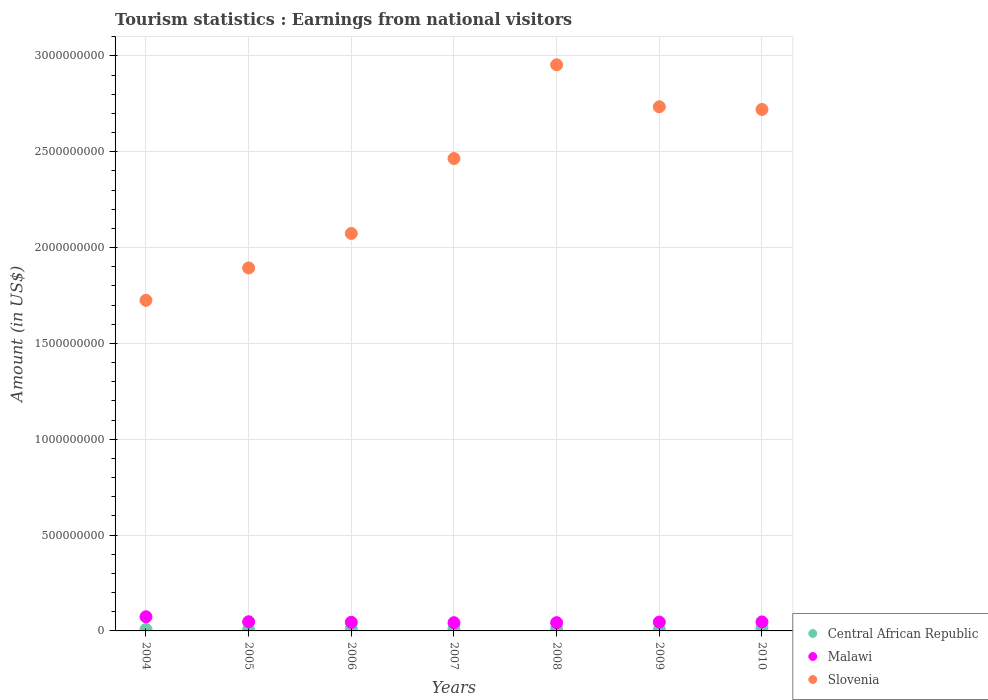How many different coloured dotlines are there?
Your answer should be compact. 3. Is the number of dotlines equal to the number of legend labels?
Provide a succinct answer. Yes. What is the earnings from national visitors in Central African Republic in 2007?
Your answer should be very brief. 1.08e+07. Across all years, what is the maximum earnings from national visitors in Central African Republic?
Make the answer very short. 1.44e+07. Across all years, what is the minimum earnings from national visitors in Central African Republic?
Ensure brevity in your answer.  7.20e+06. What is the total earnings from national visitors in Central African Republic in the graph?
Make the answer very short. 6.97e+07. What is the difference between the earnings from national visitors in Central African Republic in 2008 and that in 2010?
Provide a short and direct response. -2.60e+06. What is the difference between the earnings from national visitors in Central African Republic in 2010 and the earnings from national visitors in Slovenia in 2009?
Ensure brevity in your answer.  -2.72e+09. What is the average earnings from national visitors in Slovenia per year?
Your answer should be very brief. 2.37e+09. In the year 2006, what is the difference between the earnings from national visitors in Slovenia and earnings from national visitors in Central African Republic?
Offer a terse response. 2.06e+09. What is the ratio of the earnings from national visitors in Slovenia in 2004 to that in 2010?
Offer a very short reply. 0.63. Is the difference between the earnings from national visitors in Slovenia in 2004 and 2009 greater than the difference between the earnings from national visitors in Central African Republic in 2004 and 2009?
Provide a succinct answer. No. What is the difference between the highest and the second highest earnings from national visitors in Malawi?
Provide a succinct answer. 2.60e+07. What is the difference between the highest and the lowest earnings from national visitors in Slovenia?
Give a very brief answer. 1.23e+09. Is the earnings from national visitors in Slovenia strictly greater than the earnings from national visitors in Central African Republic over the years?
Offer a very short reply. Yes. How many dotlines are there?
Your answer should be very brief. 3. How many years are there in the graph?
Ensure brevity in your answer.  7. Does the graph contain any zero values?
Your response must be concise. No. Does the graph contain grids?
Your answer should be very brief. Yes. Where does the legend appear in the graph?
Offer a very short reply. Bottom right. How are the legend labels stacked?
Give a very brief answer. Vertical. What is the title of the graph?
Ensure brevity in your answer.  Tourism statistics : Earnings from national visitors. What is the label or title of the X-axis?
Offer a terse response. Years. What is the label or title of the Y-axis?
Make the answer very short. Amount (in US$). What is the Amount (in US$) of Central African Republic in 2004?
Your answer should be very brief. 7.80e+06. What is the Amount (in US$) of Malawi in 2004?
Make the answer very short. 7.40e+07. What is the Amount (in US$) of Slovenia in 2004?
Provide a succinct answer. 1.72e+09. What is the Amount (in US$) in Central African Republic in 2005?
Offer a terse response. 7.20e+06. What is the Amount (in US$) in Malawi in 2005?
Give a very brief answer. 4.80e+07. What is the Amount (in US$) in Slovenia in 2005?
Offer a very short reply. 1.89e+09. What is the Amount (in US$) in Central African Republic in 2006?
Give a very brief answer. 1.02e+07. What is the Amount (in US$) of Malawi in 2006?
Your response must be concise. 4.50e+07. What is the Amount (in US$) in Slovenia in 2006?
Ensure brevity in your answer.  2.07e+09. What is the Amount (in US$) of Central African Republic in 2007?
Offer a very short reply. 1.08e+07. What is the Amount (in US$) in Malawi in 2007?
Ensure brevity in your answer.  4.30e+07. What is the Amount (in US$) of Slovenia in 2007?
Offer a very short reply. 2.46e+09. What is the Amount (in US$) in Central African Republic in 2008?
Provide a succinct answer. 1.18e+07. What is the Amount (in US$) of Malawi in 2008?
Make the answer very short. 4.30e+07. What is the Amount (in US$) of Slovenia in 2008?
Ensure brevity in your answer.  2.95e+09. What is the Amount (in US$) of Central African Republic in 2009?
Offer a terse response. 7.50e+06. What is the Amount (in US$) in Malawi in 2009?
Offer a very short reply. 4.60e+07. What is the Amount (in US$) in Slovenia in 2009?
Ensure brevity in your answer.  2.74e+09. What is the Amount (in US$) of Central African Republic in 2010?
Make the answer very short. 1.44e+07. What is the Amount (in US$) of Malawi in 2010?
Give a very brief answer. 4.70e+07. What is the Amount (in US$) of Slovenia in 2010?
Ensure brevity in your answer.  2.72e+09. Across all years, what is the maximum Amount (in US$) in Central African Republic?
Keep it short and to the point. 1.44e+07. Across all years, what is the maximum Amount (in US$) in Malawi?
Keep it short and to the point. 7.40e+07. Across all years, what is the maximum Amount (in US$) in Slovenia?
Your answer should be very brief. 2.95e+09. Across all years, what is the minimum Amount (in US$) in Central African Republic?
Your response must be concise. 7.20e+06. Across all years, what is the minimum Amount (in US$) of Malawi?
Give a very brief answer. 4.30e+07. Across all years, what is the minimum Amount (in US$) of Slovenia?
Give a very brief answer. 1.72e+09. What is the total Amount (in US$) of Central African Republic in the graph?
Give a very brief answer. 6.97e+07. What is the total Amount (in US$) in Malawi in the graph?
Your response must be concise. 3.46e+08. What is the total Amount (in US$) in Slovenia in the graph?
Make the answer very short. 1.66e+1. What is the difference between the Amount (in US$) in Malawi in 2004 and that in 2005?
Keep it short and to the point. 2.60e+07. What is the difference between the Amount (in US$) in Slovenia in 2004 and that in 2005?
Ensure brevity in your answer.  -1.69e+08. What is the difference between the Amount (in US$) in Central African Republic in 2004 and that in 2006?
Provide a succinct answer. -2.40e+06. What is the difference between the Amount (in US$) of Malawi in 2004 and that in 2006?
Ensure brevity in your answer.  2.90e+07. What is the difference between the Amount (in US$) of Slovenia in 2004 and that in 2006?
Offer a terse response. -3.49e+08. What is the difference between the Amount (in US$) in Central African Republic in 2004 and that in 2007?
Make the answer very short. -3.00e+06. What is the difference between the Amount (in US$) in Malawi in 2004 and that in 2007?
Keep it short and to the point. 3.10e+07. What is the difference between the Amount (in US$) of Slovenia in 2004 and that in 2007?
Offer a terse response. -7.40e+08. What is the difference between the Amount (in US$) of Central African Republic in 2004 and that in 2008?
Provide a short and direct response. -4.00e+06. What is the difference between the Amount (in US$) in Malawi in 2004 and that in 2008?
Your answer should be very brief. 3.10e+07. What is the difference between the Amount (in US$) in Slovenia in 2004 and that in 2008?
Your response must be concise. -1.23e+09. What is the difference between the Amount (in US$) in Malawi in 2004 and that in 2009?
Provide a succinct answer. 2.80e+07. What is the difference between the Amount (in US$) of Slovenia in 2004 and that in 2009?
Your answer should be very brief. -1.01e+09. What is the difference between the Amount (in US$) in Central African Republic in 2004 and that in 2010?
Your answer should be very brief. -6.60e+06. What is the difference between the Amount (in US$) in Malawi in 2004 and that in 2010?
Offer a very short reply. 2.70e+07. What is the difference between the Amount (in US$) in Slovenia in 2004 and that in 2010?
Offer a terse response. -9.96e+08. What is the difference between the Amount (in US$) of Slovenia in 2005 and that in 2006?
Your answer should be very brief. -1.80e+08. What is the difference between the Amount (in US$) in Central African Republic in 2005 and that in 2007?
Offer a terse response. -3.60e+06. What is the difference between the Amount (in US$) of Slovenia in 2005 and that in 2007?
Keep it short and to the point. -5.71e+08. What is the difference between the Amount (in US$) in Central African Republic in 2005 and that in 2008?
Your answer should be compact. -4.60e+06. What is the difference between the Amount (in US$) in Malawi in 2005 and that in 2008?
Offer a very short reply. 5.00e+06. What is the difference between the Amount (in US$) of Slovenia in 2005 and that in 2008?
Provide a succinct answer. -1.06e+09. What is the difference between the Amount (in US$) in Malawi in 2005 and that in 2009?
Keep it short and to the point. 2.00e+06. What is the difference between the Amount (in US$) of Slovenia in 2005 and that in 2009?
Provide a short and direct response. -8.41e+08. What is the difference between the Amount (in US$) of Central African Republic in 2005 and that in 2010?
Keep it short and to the point. -7.20e+06. What is the difference between the Amount (in US$) of Malawi in 2005 and that in 2010?
Offer a terse response. 1.00e+06. What is the difference between the Amount (in US$) of Slovenia in 2005 and that in 2010?
Give a very brief answer. -8.27e+08. What is the difference between the Amount (in US$) of Central African Republic in 2006 and that in 2007?
Provide a succinct answer. -6.00e+05. What is the difference between the Amount (in US$) in Slovenia in 2006 and that in 2007?
Your answer should be compact. -3.91e+08. What is the difference between the Amount (in US$) in Central African Republic in 2006 and that in 2008?
Your response must be concise. -1.60e+06. What is the difference between the Amount (in US$) of Malawi in 2006 and that in 2008?
Ensure brevity in your answer.  2.00e+06. What is the difference between the Amount (in US$) in Slovenia in 2006 and that in 2008?
Your answer should be very brief. -8.80e+08. What is the difference between the Amount (in US$) in Central African Republic in 2006 and that in 2009?
Keep it short and to the point. 2.70e+06. What is the difference between the Amount (in US$) of Malawi in 2006 and that in 2009?
Make the answer very short. -1.00e+06. What is the difference between the Amount (in US$) in Slovenia in 2006 and that in 2009?
Provide a short and direct response. -6.61e+08. What is the difference between the Amount (in US$) in Central African Republic in 2006 and that in 2010?
Provide a succinct answer. -4.20e+06. What is the difference between the Amount (in US$) in Malawi in 2006 and that in 2010?
Your response must be concise. -2.00e+06. What is the difference between the Amount (in US$) of Slovenia in 2006 and that in 2010?
Your answer should be compact. -6.47e+08. What is the difference between the Amount (in US$) in Central African Republic in 2007 and that in 2008?
Ensure brevity in your answer.  -1.00e+06. What is the difference between the Amount (in US$) of Slovenia in 2007 and that in 2008?
Provide a short and direct response. -4.89e+08. What is the difference between the Amount (in US$) of Central African Republic in 2007 and that in 2009?
Your response must be concise. 3.30e+06. What is the difference between the Amount (in US$) of Slovenia in 2007 and that in 2009?
Your response must be concise. -2.70e+08. What is the difference between the Amount (in US$) of Central African Republic in 2007 and that in 2010?
Make the answer very short. -3.60e+06. What is the difference between the Amount (in US$) of Slovenia in 2007 and that in 2010?
Your response must be concise. -2.56e+08. What is the difference between the Amount (in US$) of Central African Republic in 2008 and that in 2009?
Provide a succinct answer. 4.30e+06. What is the difference between the Amount (in US$) of Slovenia in 2008 and that in 2009?
Your response must be concise. 2.19e+08. What is the difference between the Amount (in US$) of Central African Republic in 2008 and that in 2010?
Offer a terse response. -2.60e+06. What is the difference between the Amount (in US$) in Malawi in 2008 and that in 2010?
Your response must be concise. -4.00e+06. What is the difference between the Amount (in US$) of Slovenia in 2008 and that in 2010?
Your answer should be compact. 2.33e+08. What is the difference between the Amount (in US$) in Central African Republic in 2009 and that in 2010?
Your response must be concise. -6.90e+06. What is the difference between the Amount (in US$) in Malawi in 2009 and that in 2010?
Provide a short and direct response. -1.00e+06. What is the difference between the Amount (in US$) of Slovenia in 2009 and that in 2010?
Your answer should be very brief. 1.40e+07. What is the difference between the Amount (in US$) in Central African Republic in 2004 and the Amount (in US$) in Malawi in 2005?
Your answer should be very brief. -4.02e+07. What is the difference between the Amount (in US$) of Central African Republic in 2004 and the Amount (in US$) of Slovenia in 2005?
Provide a short and direct response. -1.89e+09. What is the difference between the Amount (in US$) of Malawi in 2004 and the Amount (in US$) of Slovenia in 2005?
Give a very brief answer. -1.82e+09. What is the difference between the Amount (in US$) in Central African Republic in 2004 and the Amount (in US$) in Malawi in 2006?
Ensure brevity in your answer.  -3.72e+07. What is the difference between the Amount (in US$) in Central African Republic in 2004 and the Amount (in US$) in Slovenia in 2006?
Ensure brevity in your answer.  -2.07e+09. What is the difference between the Amount (in US$) of Malawi in 2004 and the Amount (in US$) of Slovenia in 2006?
Your response must be concise. -2.00e+09. What is the difference between the Amount (in US$) of Central African Republic in 2004 and the Amount (in US$) of Malawi in 2007?
Keep it short and to the point. -3.52e+07. What is the difference between the Amount (in US$) in Central African Republic in 2004 and the Amount (in US$) in Slovenia in 2007?
Give a very brief answer. -2.46e+09. What is the difference between the Amount (in US$) in Malawi in 2004 and the Amount (in US$) in Slovenia in 2007?
Ensure brevity in your answer.  -2.39e+09. What is the difference between the Amount (in US$) in Central African Republic in 2004 and the Amount (in US$) in Malawi in 2008?
Your response must be concise. -3.52e+07. What is the difference between the Amount (in US$) in Central African Republic in 2004 and the Amount (in US$) in Slovenia in 2008?
Your answer should be very brief. -2.95e+09. What is the difference between the Amount (in US$) of Malawi in 2004 and the Amount (in US$) of Slovenia in 2008?
Your response must be concise. -2.88e+09. What is the difference between the Amount (in US$) of Central African Republic in 2004 and the Amount (in US$) of Malawi in 2009?
Offer a very short reply. -3.82e+07. What is the difference between the Amount (in US$) of Central African Republic in 2004 and the Amount (in US$) of Slovenia in 2009?
Give a very brief answer. -2.73e+09. What is the difference between the Amount (in US$) of Malawi in 2004 and the Amount (in US$) of Slovenia in 2009?
Offer a terse response. -2.66e+09. What is the difference between the Amount (in US$) in Central African Republic in 2004 and the Amount (in US$) in Malawi in 2010?
Provide a succinct answer. -3.92e+07. What is the difference between the Amount (in US$) of Central African Republic in 2004 and the Amount (in US$) of Slovenia in 2010?
Offer a very short reply. -2.71e+09. What is the difference between the Amount (in US$) of Malawi in 2004 and the Amount (in US$) of Slovenia in 2010?
Make the answer very short. -2.65e+09. What is the difference between the Amount (in US$) in Central African Republic in 2005 and the Amount (in US$) in Malawi in 2006?
Provide a short and direct response. -3.78e+07. What is the difference between the Amount (in US$) in Central African Republic in 2005 and the Amount (in US$) in Slovenia in 2006?
Make the answer very short. -2.07e+09. What is the difference between the Amount (in US$) in Malawi in 2005 and the Amount (in US$) in Slovenia in 2006?
Offer a very short reply. -2.03e+09. What is the difference between the Amount (in US$) in Central African Republic in 2005 and the Amount (in US$) in Malawi in 2007?
Give a very brief answer. -3.58e+07. What is the difference between the Amount (in US$) in Central African Republic in 2005 and the Amount (in US$) in Slovenia in 2007?
Your answer should be very brief. -2.46e+09. What is the difference between the Amount (in US$) in Malawi in 2005 and the Amount (in US$) in Slovenia in 2007?
Offer a very short reply. -2.42e+09. What is the difference between the Amount (in US$) in Central African Republic in 2005 and the Amount (in US$) in Malawi in 2008?
Offer a very short reply. -3.58e+07. What is the difference between the Amount (in US$) in Central African Republic in 2005 and the Amount (in US$) in Slovenia in 2008?
Offer a terse response. -2.95e+09. What is the difference between the Amount (in US$) of Malawi in 2005 and the Amount (in US$) of Slovenia in 2008?
Offer a very short reply. -2.91e+09. What is the difference between the Amount (in US$) in Central African Republic in 2005 and the Amount (in US$) in Malawi in 2009?
Provide a short and direct response. -3.88e+07. What is the difference between the Amount (in US$) of Central African Republic in 2005 and the Amount (in US$) of Slovenia in 2009?
Your answer should be very brief. -2.73e+09. What is the difference between the Amount (in US$) in Malawi in 2005 and the Amount (in US$) in Slovenia in 2009?
Keep it short and to the point. -2.69e+09. What is the difference between the Amount (in US$) of Central African Republic in 2005 and the Amount (in US$) of Malawi in 2010?
Give a very brief answer. -3.98e+07. What is the difference between the Amount (in US$) in Central African Republic in 2005 and the Amount (in US$) in Slovenia in 2010?
Offer a terse response. -2.71e+09. What is the difference between the Amount (in US$) in Malawi in 2005 and the Amount (in US$) in Slovenia in 2010?
Provide a succinct answer. -2.67e+09. What is the difference between the Amount (in US$) in Central African Republic in 2006 and the Amount (in US$) in Malawi in 2007?
Make the answer very short. -3.28e+07. What is the difference between the Amount (in US$) in Central African Republic in 2006 and the Amount (in US$) in Slovenia in 2007?
Your response must be concise. -2.45e+09. What is the difference between the Amount (in US$) in Malawi in 2006 and the Amount (in US$) in Slovenia in 2007?
Offer a terse response. -2.42e+09. What is the difference between the Amount (in US$) in Central African Republic in 2006 and the Amount (in US$) in Malawi in 2008?
Offer a very short reply. -3.28e+07. What is the difference between the Amount (in US$) of Central African Republic in 2006 and the Amount (in US$) of Slovenia in 2008?
Keep it short and to the point. -2.94e+09. What is the difference between the Amount (in US$) in Malawi in 2006 and the Amount (in US$) in Slovenia in 2008?
Provide a succinct answer. -2.91e+09. What is the difference between the Amount (in US$) in Central African Republic in 2006 and the Amount (in US$) in Malawi in 2009?
Give a very brief answer. -3.58e+07. What is the difference between the Amount (in US$) in Central African Republic in 2006 and the Amount (in US$) in Slovenia in 2009?
Offer a terse response. -2.72e+09. What is the difference between the Amount (in US$) of Malawi in 2006 and the Amount (in US$) of Slovenia in 2009?
Provide a succinct answer. -2.69e+09. What is the difference between the Amount (in US$) in Central African Republic in 2006 and the Amount (in US$) in Malawi in 2010?
Your answer should be compact. -3.68e+07. What is the difference between the Amount (in US$) in Central African Republic in 2006 and the Amount (in US$) in Slovenia in 2010?
Keep it short and to the point. -2.71e+09. What is the difference between the Amount (in US$) in Malawi in 2006 and the Amount (in US$) in Slovenia in 2010?
Make the answer very short. -2.68e+09. What is the difference between the Amount (in US$) of Central African Republic in 2007 and the Amount (in US$) of Malawi in 2008?
Offer a terse response. -3.22e+07. What is the difference between the Amount (in US$) of Central African Republic in 2007 and the Amount (in US$) of Slovenia in 2008?
Provide a short and direct response. -2.94e+09. What is the difference between the Amount (in US$) of Malawi in 2007 and the Amount (in US$) of Slovenia in 2008?
Ensure brevity in your answer.  -2.91e+09. What is the difference between the Amount (in US$) in Central African Republic in 2007 and the Amount (in US$) in Malawi in 2009?
Provide a succinct answer. -3.52e+07. What is the difference between the Amount (in US$) of Central African Republic in 2007 and the Amount (in US$) of Slovenia in 2009?
Give a very brief answer. -2.72e+09. What is the difference between the Amount (in US$) in Malawi in 2007 and the Amount (in US$) in Slovenia in 2009?
Make the answer very short. -2.69e+09. What is the difference between the Amount (in US$) in Central African Republic in 2007 and the Amount (in US$) in Malawi in 2010?
Ensure brevity in your answer.  -3.62e+07. What is the difference between the Amount (in US$) of Central African Republic in 2007 and the Amount (in US$) of Slovenia in 2010?
Offer a very short reply. -2.71e+09. What is the difference between the Amount (in US$) in Malawi in 2007 and the Amount (in US$) in Slovenia in 2010?
Give a very brief answer. -2.68e+09. What is the difference between the Amount (in US$) in Central African Republic in 2008 and the Amount (in US$) in Malawi in 2009?
Keep it short and to the point. -3.42e+07. What is the difference between the Amount (in US$) of Central African Republic in 2008 and the Amount (in US$) of Slovenia in 2009?
Provide a succinct answer. -2.72e+09. What is the difference between the Amount (in US$) in Malawi in 2008 and the Amount (in US$) in Slovenia in 2009?
Ensure brevity in your answer.  -2.69e+09. What is the difference between the Amount (in US$) of Central African Republic in 2008 and the Amount (in US$) of Malawi in 2010?
Offer a terse response. -3.52e+07. What is the difference between the Amount (in US$) of Central African Republic in 2008 and the Amount (in US$) of Slovenia in 2010?
Ensure brevity in your answer.  -2.71e+09. What is the difference between the Amount (in US$) in Malawi in 2008 and the Amount (in US$) in Slovenia in 2010?
Give a very brief answer. -2.68e+09. What is the difference between the Amount (in US$) of Central African Republic in 2009 and the Amount (in US$) of Malawi in 2010?
Provide a succinct answer. -3.95e+07. What is the difference between the Amount (in US$) of Central African Republic in 2009 and the Amount (in US$) of Slovenia in 2010?
Provide a succinct answer. -2.71e+09. What is the difference between the Amount (in US$) in Malawi in 2009 and the Amount (in US$) in Slovenia in 2010?
Your answer should be very brief. -2.68e+09. What is the average Amount (in US$) of Central African Republic per year?
Make the answer very short. 9.96e+06. What is the average Amount (in US$) in Malawi per year?
Provide a short and direct response. 4.94e+07. What is the average Amount (in US$) in Slovenia per year?
Your answer should be compact. 2.37e+09. In the year 2004, what is the difference between the Amount (in US$) of Central African Republic and Amount (in US$) of Malawi?
Ensure brevity in your answer.  -6.62e+07. In the year 2004, what is the difference between the Amount (in US$) in Central African Republic and Amount (in US$) in Slovenia?
Keep it short and to the point. -1.72e+09. In the year 2004, what is the difference between the Amount (in US$) of Malawi and Amount (in US$) of Slovenia?
Make the answer very short. -1.65e+09. In the year 2005, what is the difference between the Amount (in US$) in Central African Republic and Amount (in US$) in Malawi?
Your response must be concise. -4.08e+07. In the year 2005, what is the difference between the Amount (in US$) of Central African Republic and Amount (in US$) of Slovenia?
Provide a short and direct response. -1.89e+09. In the year 2005, what is the difference between the Amount (in US$) of Malawi and Amount (in US$) of Slovenia?
Your answer should be very brief. -1.85e+09. In the year 2006, what is the difference between the Amount (in US$) in Central African Republic and Amount (in US$) in Malawi?
Offer a terse response. -3.48e+07. In the year 2006, what is the difference between the Amount (in US$) in Central African Republic and Amount (in US$) in Slovenia?
Offer a terse response. -2.06e+09. In the year 2006, what is the difference between the Amount (in US$) in Malawi and Amount (in US$) in Slovenia?
Offer a terse response. -2.03e+09. In the year 2007, what is the difference between the Amount (in US$) of Central African Republic and Amount (in US$) of Malawi?
Provide a short and direct response. -3.22e+07. In the year 2007, what is the difference between the Amount (in US$) of Central African Republic and Amount (in US$) of Slovenia?
Offer a very short reply. -2.45e+09. In the year 2007, what is the difference between the Amount (in US$) in Malawi and Amount (in US$) in Slovenia?
Provide a succinct answer. -2.42e+09. In the year 2008, what is the difference between the Amount (in US$) of Central African Republic and Amount (in US$) of Malawi?
Offer a terse response. -3.12e+07. In the year 2008, what is the difference between the Amount (in US$) of Central African Republic and Amount (in US$) of Slovenia?
Your response must be concise. -2.94e+09. In the year 2008, what is the difference between the Amount (in US$) of Malawi and Amount (in US$) of Slovenia?
Provide a succinct answer. -2.91e+09. In the year 2009, what is the difference between the Amount (in US$) in Central African Republic and Amount (in US$) in Malawi?
Keep it short and to the point. -3.85e+07. In the year 2009, what is the difference between the Amount (in US$) in Central African Republic and Amount (in US$) in Slovenia?
Offer a very short reply. -2.73e+09. In the year 2009, what is the difference between the Amount (in US$) of Malawi and Amount (in US$) of Slovenia?
Provide a succinct answer. -2.69e+09. In the year 2010, what is the difference between the Amount (in US$) of Central African Republic and Amount (in US$) of Malawi?
Your answer should be compact. -3.26e+07. In the year 2010, what is the difference between the Amount (in US$) of Central African Republic and Amount (in US$) of Slovenia?
Offer a terse response. -2.71e+09. In the year 2010, what is the difference between the Amount (in US$) of Malawi and Amount (in US$) of Slovenia?
Your answer should be very brief. -2.67e+09. What is the ratio of the Amount (in US$) in Malawi in 2004 to that in 2005?
Offer a terse response. 1.54. What is the ratio of the Amount (in US$) of Slovenia in 2004 to that in 2005?
Offer a terse response. 0.91. What is the ratio of the Amount (in US$) in Central African Republic in 2004 to that in 2006?
Offer a terse response. 0.76. What is the ratio of the Amount (in US$) in Malawi in 2004 to that in 2006?
Provide a succinct answer. 1.64. What is the ratio of the Amount (in US$) in Slovenia in 2004 to that in 2006?
Your response must be concise. 0.83. What is the ratio of the Amount (in US$) in Central African Republic in 2004 to that in 2007?
Ensure brevity in your answer.  0.72. What is the ratio of the Amount (in US$) in Malawi in 2004 to that in 2007?
Give a very brief answer. 1.72. What is the ratio of the Amount (in US$) in Slovenia in 2004 to that in 2007?
Your response must be concise. 0.7. What is the ratio of the Amount (in US$) of Central African Republic in 2004 to that in 2008?
Ensure brevity in your answer.  0.66. What is the ratio of the Amount (in US$) in Malawi in 2004 to that in 2008?
Your answer should be very brief. 1.72. What is the ratio of the Amount (in US$) in Slovenia in 2004 to that in 2008?
Offer a terse response. 0.58. What is the ratio of the Amount (in US$) of Malawi in 2004 to that in 2009?
Your answer should be compact. 1.61. What is the ratio of the Amount (in US$) in Slovenia in 2004 to that in 2009?
Give a very brief answer. 0.63. What is the ratio of the Amount (in US$) in Central African Republic in 2004 to that in 2010?
Ensure brevity in your answer.  0.54. What is the ratio of the Amount (in US$) in Malawi in 2004 to that in 2010?
Make the answer very short. 1.57. What is the ratio of the Amount (in US$) of Slovenia in 2004 to that in 2010?
Provide a succinct answer. 0.63. What is the ratio of the Amount (in US$) in Central African Republic in 2005 to that in 2006?
Give a very brief answer. 0.71. What is the ratio of the Amount (in US$) of Malawi in 2005 to that in 2006?
Make the answer very short. 1.07. What is the ratio of the Amount (in US$) in Slovenia in 2005 to that in 2006?
Offer a terse response. 0.91. What is the ratio of the Amount (in US$) in Malawi in 2005 to that in 2007?
Provide a succinct answer. 1.12. What is the ratio of the Amount (in US$) in Slovenia in 2005 to that in 2007?
Give a very brief answer. 0.77. What is the ratio of the Amount (in US$) in Central African Republic in 2005 to that in 2008?
Your answer should be compact. 0.61. What is the ratio of the Amount (in US$) in Malawi in 2005 to that in 2008?
Your response must be concise. 1.12. What is the ratio of the Amount (in US$) in Slovenia in 2005 to that in 2008?
Keep it short and to the point. 0.64. What is the ratio of the Amount (in US$) in Central African Republic in 2005 to that in 2009?
Ensure brevity in your answer.  0.96. What is the ratio of the Amount (in US$) of Malawi in 2005 to that in 2009?
Keep it short and to the point. 1.04. What is the ratio of the Amount (in US$) of Slovenia in 2005 to that in 2009?
Offer a terse response. 0.69. What is the ratio of the Amount (in US$) in Central African Republic in 2005 to that in 2010?
Provide a short and direct response. 0.5. What is the ratio of the Amount (in US$) of Malawi in 2005 to that in 2010?
Give a very brief answer. 1.02. What is the ratio of the Amount (in US$) in Slovenia in 2005 to that in 2010?
Your response must be concise. 0.7. What is the ratio of the Amount (in US$) of Malawi in 2006 to that in 2007?
Your answer should be very brief. 1.05. What is the ratio of the Amount (in US$) in Slovenia in 2006 to that in 2007?
Make the answer very short. 0.84. What is the ratio of the Amount (in US$) in Central African Republic in 2006 to that in 2008?
Give a very brief answer. 0.86. What is the ratio of the Amount (in US$) of Malawi in 2006 to that in 2008?
Offer a very short reply. 1.05. What is the ratio of the Amount (in US$) of Slovenia in 2006 to that in 2008?
Offer a terse response. 0.7. What is the ratio of the Amount (in US$) of Central African Republic in 2006 to that in 2009?
Your answer should be compact. 1.36. What is the ratio of the Amount (in US$) of Malawi in 2006 to that in 2009?
Offer a terse response. 0.98. What is the ratio of the Amount (in US$) of Slovenia in 2006 to that in 2009?
Keep it short and to the point. 0.76. What is the ratio of the Amount (in US$) in Central African Republic in 2006 to that in 2010?
Give a very brief answer. 0.71. What is the ratio of the Amount (in US$) in Malawi in 2006 to that in 2010?
Provide a short and direct response. 0.96. What is the ratio of the Amount (in US$) of Slovenia in 2006 to that in 2010?
Your response must be concise. 0.76. What is the ratio of the Amount (in US$) in Central African Republic in 2007 to that in 2008?
Give a very brief answer. 0.92. What is the ratio of the Amount (in US$) of Slovenia in 2007 to that in 2008?
Your response must be concise. 0.83. What is the ratio of the Amount (in US$) in Central African Republic in 2007 to that in 2009?
Provide a succinct answer. 1.44. What is the ratio of the Amount (in US$) in Malawi in 2007 to that in 2009?
Offer a terse response. 0.93. What is the ratio of the Amount (in US$) in Slovenia in 2007 to that in 2009?
Provide a short and direct response. 0.9. What is the ratio of the Amount (in US$) of Central African Republic in 2007 to that in 2010?
Give a very brief answer. 0.75. What is the ratio of the Amount (in US$) of Malawi in 2007 to that in 2010?
Provide a short and direct response. 0.91. What is the ratio of the Amount (in US$) in Slovenia in 2007 to that in 2010?
Provide a succinct answer. 0.91. What is the ratio of the Amount (in US$) of Central African Republic in 2008 to that in 2009?
Your answer should be compact. 1.57. What is the ratio of the Amount (in US$) in Malawi in 2008 to that in 2009?
Offer a terse response. 0.93. What is the ratio of the Amount (in US$) in Slovenia in 2008 to that in 2009?
Give a very brief answer. 1.08. What is the ratio of the Amount (in US$) in Central African Republic in 2008 to that in 2010?
Provide a succinct answer. 0.82. What is the ratio of the Amount (in US$) in Malawi in 2008 to that in 2010?
Keep it short and to the point. 0.91. What is the ratio of the Amount (in US$) of Slovenia in 2008 to that in 2010?
Your response must be concise. 1.09. What is the ratio of the Amount (in US$) in Central African Republic in 2009 to that in 2010?
Your answer should be compact. 0.52. What is the ratio of the Amount (in US$) of Malawi in 2009 to that in 2010?
Your answer should be compact. 0.98. What is the ratio of the Amount (in US$) of Slovenia in 2009 to that in 2010?
Offer a terse response. 1.01. What is the difference between the highest and the second highest Amount (in US$) of Central African Republic?
Your answer should be very brief. 2.60e+06. What is the difference between the highest and the second highest Amount (in US$) in Malawi?
Offer a very short reply. 2.60e+07. What is the difference between the highest and the second highest Amount (in US$) of Slovenia?
Offer a very short reply. 2.19e+08. What is the difference between the highest and the lowest Amount (in US$) in Central African Republic?
Your answer should be very brief. 7.20e+06. What is the difference between the highest and the lowest Amount (in US$) of Malawi?
Your answer should be very brief. 3.10e+07. What is the difference between the highest and the lowest Amount (in US$) in Slovenia?
Provide a short and direct response. 1.23e+09. 